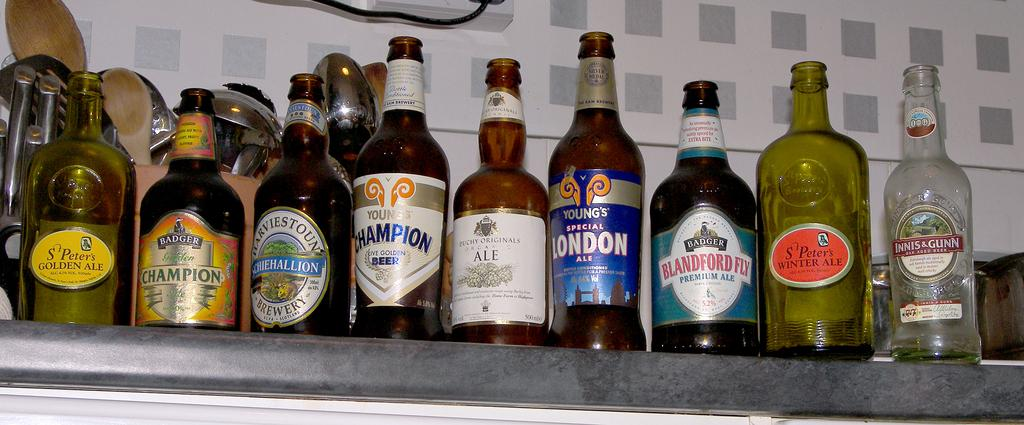<image>
Summarize the visual content of the image. Various beer bottles stacked in a row, with one saying Young's Special London Ale 